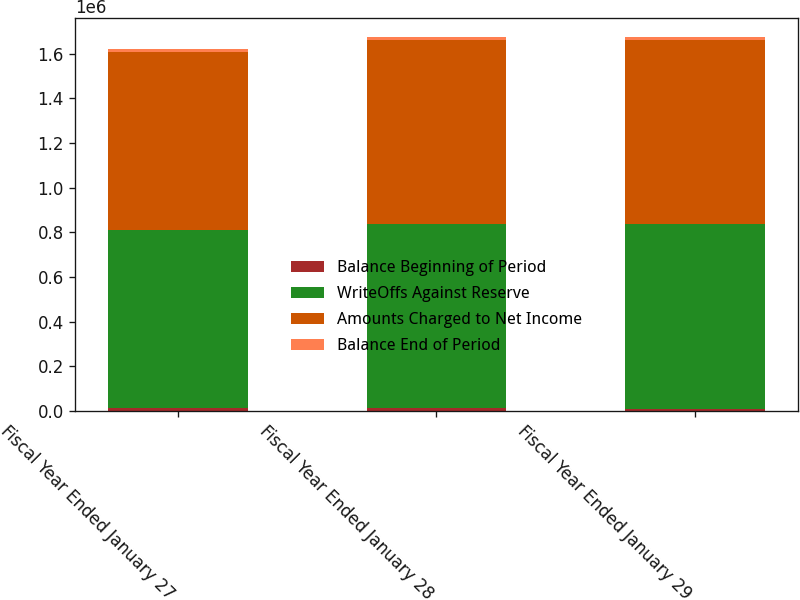<chart> <loc_0><loc_0><loc_500><loc_500><stacked_bar_chart><ecel><fcel>Fiscal Year Ended January 27<fcel>Fiscal Year Ended January 28<fcel>Fiscal Year Ended January 29<nl><fcel>Balance Beginning of Period<fcel>14101<fcel>13162<fcel>11596<nl><fcel>WriteOffs Against Reserve<fcel>795941<fcel>823357<fcel>825795<nl><fcel>Amounts Charged to Net Income<fcel>795860<fcel>822418<fcel>824229<nl><fcel>Balance End of Period<fcel>14182<fcel>14101<fcel>13162<nl></chart> 